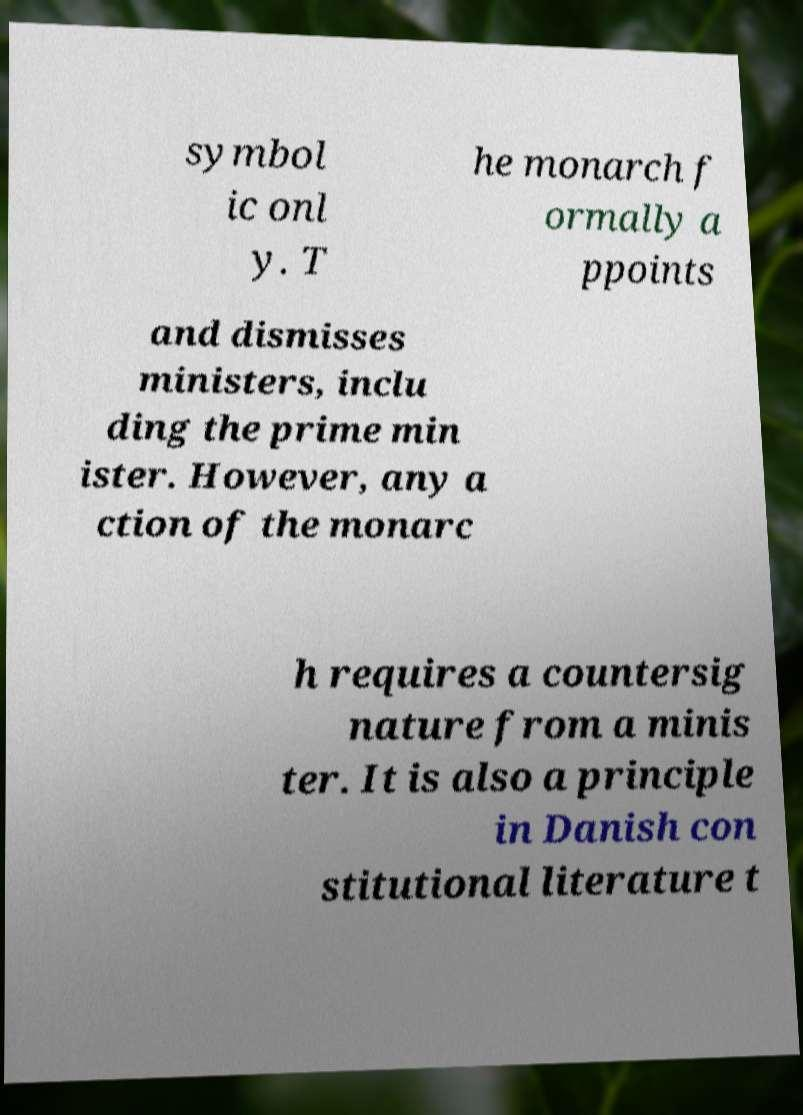Can you read and provide the text displayed in the image?This photo seems to have some interesting text. Can you extract and type it out for me? symbol ic onl y. T he monarch f ormally a ppoints and dismisses ministers, inclu ding the prime min ister. However, any a ction of the monarc h requires a countersig nature from a minis ter. It is also a principle in Danish con stitutional literature t 